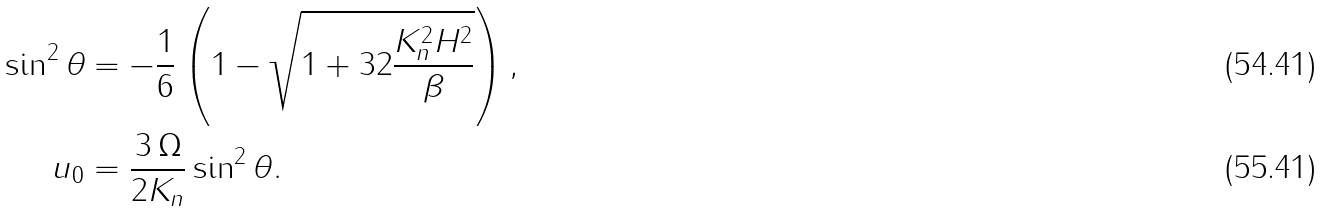<formula> <loc_0><loc_0><loc_500><loc_500>\sin ^ { 2 } \theta & = - \frac { 1 } { 6 } \left ( 1 - \sqrt { 1 + 3 2 \frac { K _ { n } ^ { 2 } H ^ { 2 } } { \beta } } \right ) , \\ u _ { 0 } & = \frac { 3 \, \Omega } { 2 K _ { n } } \sin ^ { 2 } \theta .</formula> 